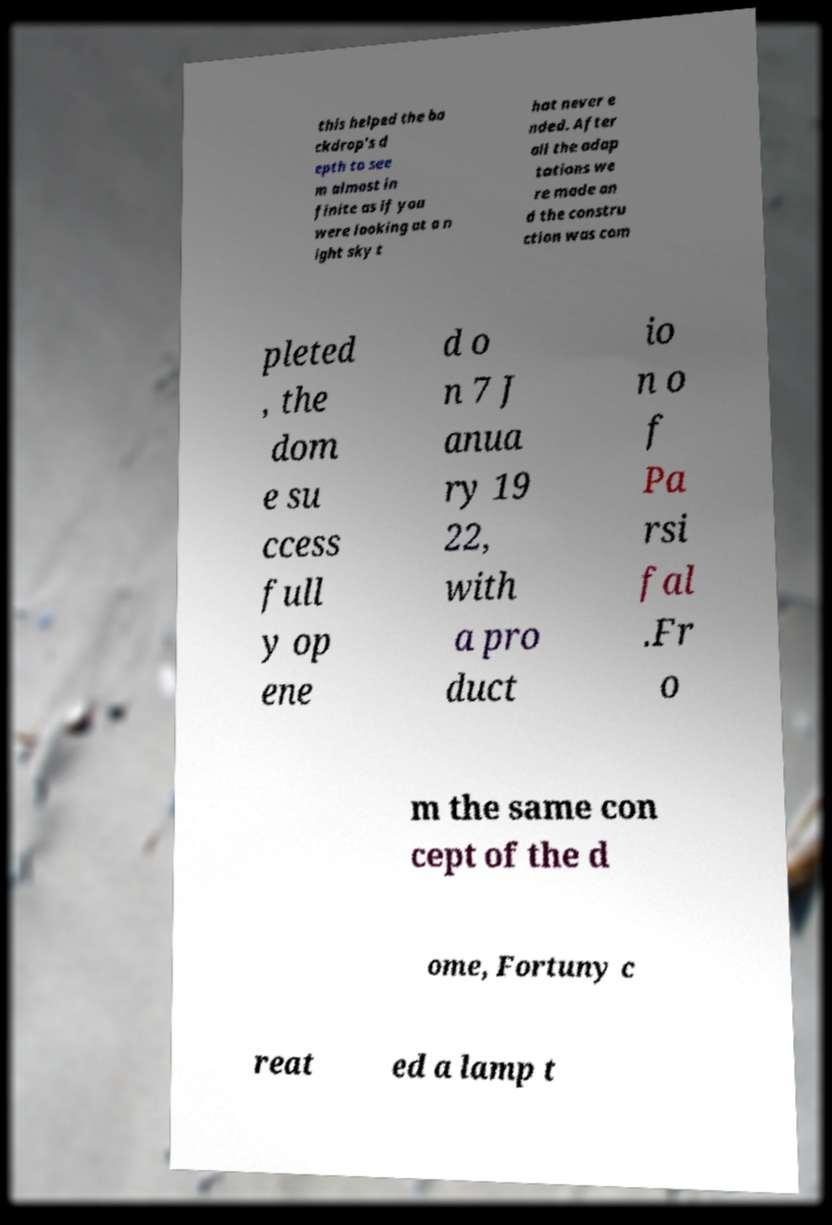Could you extract and type out the text from this image? this helped the ba ckdrop’s d epth to see m almost in finite as if you were looking at a n ight sky t hat never e nded. After all the adap tations we re made an d the constru ction was com pleted , the dom e su ccess full y op ene d o n 7 J anua ry 19 22, with a pro duct io n o f Pa rsi fal .Fr o m the same con cept of the d ome, Fortuny c reat ed a lamp t 